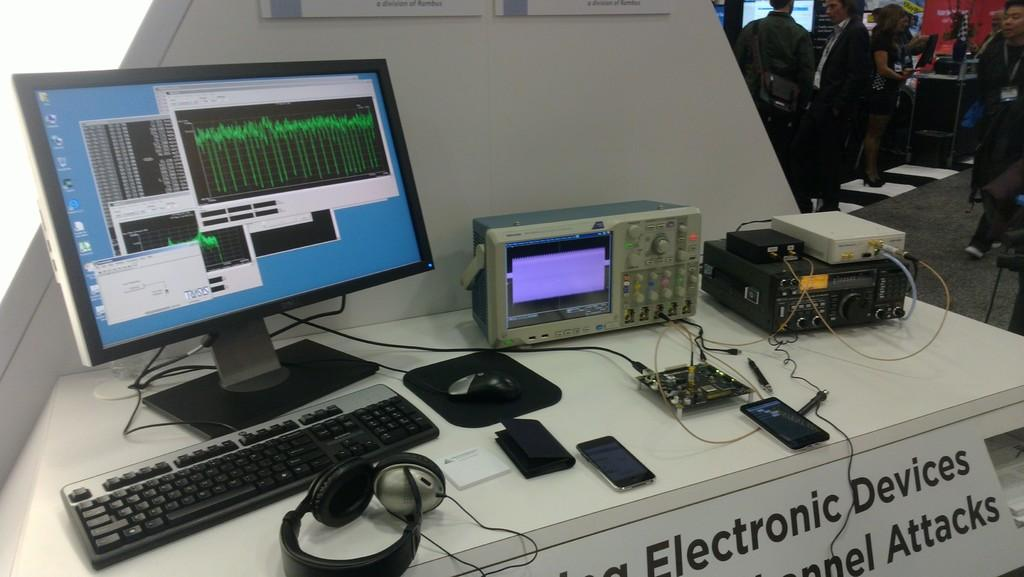<image>
Present a compact description of the photo's key features. A sign mentioning Electronic Devices is visible under an array of computer equipment. 